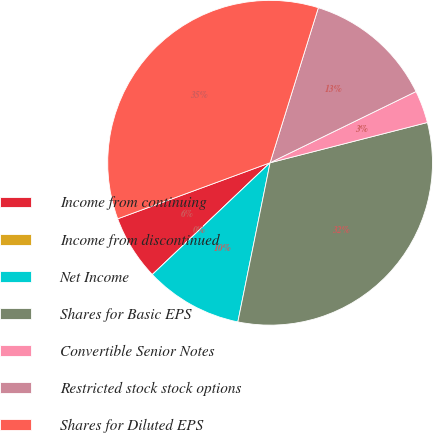Convert chart. <chart><loc_0><loc_0><loc_500><loc_500><pie_chart><fcel>Income from continuing<fcel>Income from discontinued<fcel>Net Income<fcel>Shares for Basic EPS<fcel>Convertible Senior Notes<fcel>Restricted stock stock options<fcel>Shares for Diluted EPS<nl><fcel>6.48%<fcel>0.0%<fcel>9.73%<fcel>32.17%<fcel>3.24%<fcel>12.97%<fcel>35.41%<nl></chart> 